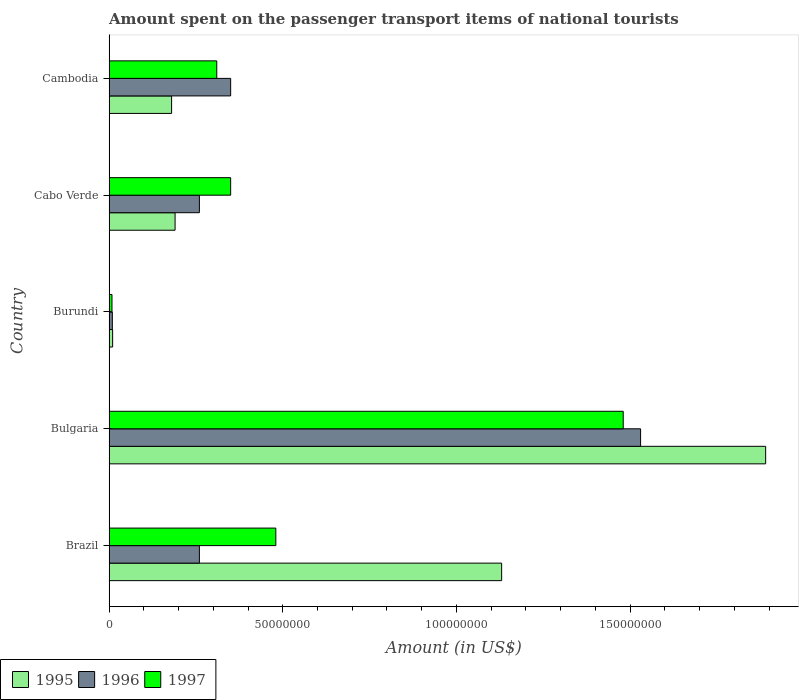How many groups of bars are there?
Ensure brevity in your answer.  5. How many bars are there on the 2nd tick from the top?
Provide a short and direct response. 3. How many bars are there on the 2nd tick from the bottom?
Make the answer very short. 3. What is the label of the 1st group of bars from the top?
Your response must be concise. Cambodia. What is the amount spent on the passenger transport items of national tourists in 1997 in Bulgaria?
Provide a succinct answer. 1.48e+08. Across all countries, what is the maximum amount spent on the passenger transport items of national tourists in 1995?
Your answer should be very brief. 1.89e+08. Across all countries, what is the minimum amount spent on the passenger transport items of national tourists in 1995?
Your answer should be compact. 1.02e+06. In which country was the amount spent on the passenger transport items of national tourists in 1996 minimum?
Your answer should be compact. Burundi. What is the total amount spent on the passenger transport items of national tourists in 1995 in the graph?
Make the answer very short. 3.40e+08. What is the difference between the amount spent on the passenger transport items of national tourists in 1997 in Bulgaria and that in Cambodia?
Make the answer very short. 1.17e+08. What is the difference between the amount spent on the passenger transport items of national tourists in 1995 in Cabo Verde and the amount spent on the passenger transport items of national tourists in 1996 in Cambodia?
Make the answer very short. -1.60e+07. What is the average amount spent on the passenger transport items of national tourists in 1997 per country?
Your answer should be very brief. 5.26e+07. What is the difference between the amount spent on the passenger transport items of national tourists in 1995 and amount spent on the passenger transport items of national tourists in 1996 in Burundi?
Your answer should be very brief. 8.36e+04. What is the ratio of the amount spent on the passenger transport items of national tourists in 1997 in Bulgaria to that in Burundi?
Make the answer very short. 176.18. Is the difference between the amount spent on the passenger transport items of national tourists in 1995 in Bulgaria and Cambodia greater than the difference between the amount spent on the passenger transport items of national tourists in 1996 in Bulgaria and Cambodia?
Offer a terse response. Yes. What is the difference between the highest and the second highest amount spent on the passenger transport items of national tourists in 1995?
Make the answer very short. 7.60e+07. What is the difference between the highest and the lowest amount spent on the passenger transport items of national tourists in 1996?
Keep it short and to the point. 1.52e+08. What does the 2nd bar from the bottom in Burundi represents?
Provide a short and direct response. 1996. Is it the case that in every country, the sum of the amount spent on the passenger transport items of national tourists in 1995 and amount spent on the passenger transport items of national tourists in 1997 is greater than the amount spent on the passenger transport items of national tourists in 1996?
Provide a short and direct response. Yes. How many countries are there in the graph?
Your answer should be very brief. 5. Are the values on the major ticks of X-axis written in scientific E-notation?
Keep it short and to the point. No. Where does the legend appear in the graph?
Provide a short and direct response. Bottom left. What is the title of the graph?
Provide a short and direct response. Amount spent on the passenger transport items of national tourists. What is the Amount (in US$) in 1995 in Brazil?
Provide a succinct answer. 1.13e+08. What is the Amount (in US$) in 1996 in Brazil?
Offer a terse response. 2.60e+07. What is the Amount (in US$) of 1997 in Brazil?
Keep it short and to the point. 4.80e+07. What is the Amount (in US$) of 1995 in Bulgaria?
Keep it short and to the point. 1.89e+08. What is the Amount (in US$) in 1996 in Bulgaria?
Make the answer very short. 1.53e+08. What is the Amount (in US$) of 1997 in Bulgaria?
Your response must be concise. 1.48e+08. What is the Amount (in US$) of 1995 in Burundi?
Your response must be concise. 1.02e+06. What is the Amount (in US$) of 1996 in Burundi?
Your response must be concise. 9.41e+05. What is the Amount (in US$) of 1997 in Burundi?
Make the answer very short. 8.40e+05. What is the Amount (in US$) in 1995 in Cabo Verde?
Offer a very short reply. 1.90e+07. What is the Amount (in US$) of 1996 in Cabo Verde?
Provide a short and direct response. 2.60e+07. What is the Amount (in US$) in 1997 in Cabo Verde?
Your answer should be compact. 3.50e+07. What is the Amount (in US$) of 1995 in Cambodia?
Provide a short and direct response. 1.80e+07. What is the Amount (in US$) in 1996 in Cambodia?
Offer a very short reply. 3.50e+07. What is the Amount (in US$) in 1997 in Cambodia?
Your answer should be very brief. 3.10e+07. Across all countries, what is the maximum Amount (in US$) of 1995?
Your response must be concise. 1.89e+08. Across all countries, what is the maximum Amount (in US$) in 1996?
Offer a very short reply. 1.53e+08. Across all countries, what is the maximum Amount (in US$) in 1997?
Provide a short and direct response. 1.48e+08. Across all countries, what is the minimum Amount (in US$) of 1995?
Provide a succinct answer. 1.02e+06. Across all countries, what is the minimum Amount (in US$) in 1996?
Offer a very short reply. 9.41e+05. Across all countries, what is the minimum Amount (in US$) of 1997?
Your answer should be compact. 8.40e+05. What is the total Amount (in US$) of 1995 in the graph?
Your answer should be very brief. 3.40e+08. What is the total Amount (in US$) in 1996 in the graph?
Give a very brief answer. 2.41e+08. What is the total Amount (in US$) of 1997 in the graph?
Offer a terse response. 2.63e+08. What is the difference between the Amount (in US$) in 1995 in Brazil and that in Bulgaria?
Give a very brief answer. -7.60e+07. What is the difference between the Amount (in US$) in 1996 in Brazil and that in Bulgaria?
Your answer should be very brief. -1.27e+08. What is the difference between the Amount (in US$) of 1997 in Brazil and that in Bulgaria?
Offer a terse response. -1.00e+08. What is the difference between the Amount (in US$) in 1995 in Brazil and that in Burundi?
Provide a short and direct response. 1.12e+08. What is the difference between the Amount (in US$) in 1996 in Brazil and that in Burundi?
Your answer should be compact. 2.51e+07. What is the difference between the Amount (in US$) in 1997 in Brazil and that in Burundi?
Your answer should be compact. 4.72e+07. What is the difference between the Amount (in US$) of 1995 in Brazil and that in Cabo Verde?
Provide a succinct answer. 9.40e+07. What is the difference between the Amount (in US$) of 1996 in Brazil and that in Cabo Verde?
Give a very brief answer. 0. What is the difference between the Amount (in US$) in 1997 in Brazil and that in Cabo Verde?
Offer a terse response. 1.30e+07. What is the difference between the Amount (in US$) in 1995 in Brazil and that in Cambodia?
Your answer should be very brief. 9.50e+07. What is the difference between the Amount (in US$) in 1996 in Brazil and that in Cambodia?
Your answer should be very brief. -9.00e+06. What is the difference between the Amount (in US$) in 1997 in Brazil and that in Cambodia?
Make the answer very short. 1.70e+07. What is the difference between the Amount (in US$) in 1995 in Bulgaria and that in Burundi?
Offer a very short reply. 1.88e+08. What is the difference between the Amount (in US$) of 1996 in Bulgaria and that in Burundi?
Your response must be concise. 1.52e+08. What is the difference between the Amount (in US$) in 1997 in Bulgaria and that in Burundi?
Offer a terse response. 1.47e+08. What is the difference between the Amount (in US$) of 1995 in Bulgaria and that in Cabo Verde?
Make the answer very short. 1.70e+08. What is the difference between the Amount (in US$) in 1996 in Bulgaria and that in Cabo Verde?
Make the answer very short. 1.27e+08. What is the difference between the Amount (in US$) of 1997 in Bulgaria and that in Cabo Verde?
Ensure brevity in your answer.  1.13e+08. What is the difference between the Amount (in US$) of 1995 in Bulgaria and that in Cambodia?
Offer a terse response. 1.71e+08. What is the difference between the Amount (in US$) of 1996 in Bulgaria and that in Cambodia?
Give a very brief answer. 1.18e+08. What is the difference between the Amount (in US$) in 1997 in Bulgaria and that in Cambodia?
Your answer should be very brief. 1.17e+08. What is the difference between the Amount (in US$) of 1995 in Burundi and that in Cabo Verde?
Offer a terse response. -1.80e+07. What is the difference between the Amount (in US$) of 1996 in Burundi and that in Cabo Verde?
Give a very brief answer. -2.51e+07. What is the difference between the Amount (in US$) of 1997 in Burundi and that in Cabo Verde?
Offer a terse response. -3.42e+07. What is the difference between the Amount (in US$) in 1995 in Burundi and that in Cambodia?
Offer a very short reply. -1.70e+07. What is the difference between the Amount (in US$) in 1996 in Burundi and that in Cambodia?
Offer a terse response. -3.41e+07. What is the difference between the Amount (in US$) in 1997 in Burundi and that in Cambodia?
Provide a short and direct response. -3.02e+07. What is the difference between the Amount (in US$) of 1995 in Cabo Verde and that in Cambodia?
Your response must be concise. 1.00e+06. What is the difference between the Amount (in US$) in 1996 in Cabo Verde and that in Cambodia?
Provide a succinct answer. -9.00e+06. What is the difference between the Amount (in US$) in 1995 in Brazil and the Amount (in US$) in 1996 in Bulgaria?
Offer a very short reply. -4.00e+07. What is the difference between the Amount (in US$) of 1995 in Brazil and the Amount (in US$) of 1997 in Bulgaria?
Offer a terse response. -3.50e+07. What is the difference between the Amount (in US$) of 1996 in Brazil and the Amount (in US$) of 1997 in Bulgaria?
Make the answer very short. -1.22e+08. What is the difference between the Amount (in US$) in 1995 in Brazil and the Amount (in US$) in 1996 in Burundi?
Offer a terse response. 1.12e+08. What is the difference between the Amount (in US$) in 1995 in Brazil and the Amount (in US$) in 1997 in Burundi?
Provide a succinct answer. 1.12e+08. What is the difference between the Amount (in US$) in 1996 in Brazil and the Amount (in US$) in 1997 in Burundi?
Your answer should be very brief. 2.52e+07. What is the difference between the Amount (in US$) of 1995 in Brazil and the Amount (in US$) of 1996 in Cabo Verde?
Provide a succinct answer. 8.70e+07. What is the difference between the Amount (in US$) of 1995 in Brazil and the Amount (in US$) of 1997 in Cabo Verde?
Your answer should be compact. 7.80e+07. What is the difference between the Amount (in US$) in 1996 in Brazil and the Amount (in US$) in 1997 in Cabo Verde?
Ensure brevity in your answer.  -9.00e+06. What is the difference between the Amount (in US$) in 1995 in Brazil and the Amount (in US$) in 1996 in Cambodia?
Provide a succinct answer. 7.80e+07. What is the difference between the Amount (in US$) in 1995 in Brazil and the Amount (in US$) in 1997 in Cambodia?
Ensure brevity in your answer.  8.20e+07. What is the difference between the Amount (in US$) in 1996 in Brazil and the Amount (in US$) in 1997 in Cambodia?
Your response must be concise. -5.00e+06. What is the difference between the Amount (in US$) in 1995 in Bulgaria and the Amount (in US$) in 1996 in Burundi?
Your answer should be very brief. 1.88e+08. What is the difference between the Amount (in US$) in 1995 in Bulgaria and the Amount (in US$) in 1997 in Burundi?
Your answer should be compact. 1.88e+08. What is the difference between the Amount (in US$) of 1996 in Bulgaria and the Amount (in US$) of 1997 in Burundi?
Your answer should be very brief. 1.52e+08. What is the difference between the Amount (in US$) in 1995 in Bulgaria and the Amount (in US$) in 1996 in Cabo Verde?
Provide a short and direct response. 1.63e+08. What is the difference between the Amount (in US$) of 1995 in Bulgaria and the Amount (in US$) of 1997 in Cabo Verde?
Offer a very short reply. 1.54e+08. What is the difference between the Amount (in US$) in 1996 in Bulgaria and the Amount (in US$) in 1997 in Cabo Verde?
Keep it short and to the point. 1.18e+08. What is the difference between the Amount (in US$) of 1995 in Bulgaria and the Amount (in US$) of 1996 in Cambodia?
Ensure brevity in your answer.  1.54e+08. What is the difference between the Amount (in US$) in 1995 in Bulgaria and the Amount (in US$) in 1997 in Cambodia?
Your answer should be compact. 1.58e+08. What is the difference between the Amount (in US$) in 1996 in Bulgaria and the Amount (in US$) in 1997 in Cambodia?
Make the answer very short. 1.22e+08. What is the difference between the Amount (in US$) of 1995 in Burundi and the Amount (in US$) of 1996 in Cabo Verde?
Provide a short and direct response. -2.50e+07. What is the difference between the Amount (in US$) of 1995 in Burundi and the Amount (in US$) of 1997 in Cabo Verde?
Keep it short and to the point. -3.40e+07. What is the difference between the Amount (in US$) of 1996 in Burundi and the Amount (in US$) of 1997 in Cabo Verde?
Give a very brief answer. -3.41e+07. What is the difference between the Amount (in US$) of 1995 in Burundi and the Amount (in US$) of 1996 in Cambodia?
Your answer should be compact. -3.40e+07. What is the difference between the Amount (in US$) of 1995 in Burundi and the Amount (in US$) of 1997 in Cambodia?
Provide a succinct answer. -3.00e+07. What is the difference between the Amount (in US$) in 1996 in Burundi and the Amount (in US$) in 1997 in Cambodia?
Your answer should be very brief. -3.01e+07. What is the difference between the Amount (in US$) of 1995 in Cabo Verde and the Amount (in US$) of 1996 in Cambodia?
Your answer should be compact. -1.60e+07. What is the difference between the Amount (in US$) in 1995 in Cabo Verde and the Amount (in US$) in 1997 in Cambodia?
Your response must be concise. -1.20e+07. What is the difference between the Amount (in US$) in 1996 in Cabo Verde and the Amount (in US$) in 1997 in Cambodia?
Give a very brief answer. -5.00e+06. What is the average Amount (in US$) in 1995 per country?
Provide a succinct answer. 6.80e+07. What is the average Amount (in US$) in 1996 per country?
Offer a terse response. 4.82e+07. What is the average Amount (in US$) of 1997 per country?
Keep it short and to the point. 5.26e+07. What is the difference between the Amount (in US$) in 1995 and Amount (in US$) in 1996 in Brazil?
Ensure brevity in your answer.  8.70e+07. What is the difference between the Amount (in US$) in 1995 and Amount (in US$) in 1997 in Brazil?
Offer a very short reply. 6.50e+07. What is the difference between the Amount (in US$) of 1996 and Amount (in US$) of 1997 in Brazil?
Give a very brief answer. -2.20e+07. What is the difference between the Amount (in US$) of 1995 and Amount (in US$) of 1996 in Bulgaria?
Make the answer very short. 3.60e+07. What is the difference between the Amount (in US$) of 1995 and Amount (in US$) of 1997 in Bulgaria?
Offer a terse response. 4.10e+07. What is the difference between the Amount (in US$) of 1995 and Amount (in US$) of 1996 in Burundi?
Your answer should be very brief. 8.36e+04. What is the difference between the Amount (in US$) of 1995 and Amount (in US$) of 1997 in Burundi?
Offer a terse response. 1.85e+05. What is the difference between the Amount (in US$) in 1996 and Amount (in US$) in 1997 in Burundi?
Keep it short and to the point. 1.01e+05. What is the difference between the Amount (in US$) of 1995 and Amount (in US$) of 1996 in Cabo Verde?
Provide a short and direct response. -7.00e+06. What is the difference between the Amount (in US$) in 1995 and Amount (in US$) in 1997 in Cabo Verde?
Ensure brevity in your answer.  -1.60e+07. What is the difference between the Amount (in US$) of 1996 and Amount (in US$) of 1997 in Cabo Verde?
Make the answer very short. -9.00e+06. What is the difference between the Amount (in US$) in 1995 and Amount (in US$) in 1996 in Cambodia?
Your response must be concise. -1.70e+07. What is the difference between the Amount (in US$) of 1995 and Amount (in US$) of 1997 in Cambodia?
Your answer should be compact. -1.30e+07. What is the difference between the Amount (in US$) in 1996 and Amount (in US$) in 1997 in Cambodia?
Your response must be concise. 4.00e+06. What is the ratio of the Amount (in US$) of 1995 in Brazil to that in Bulgaria?
Make the answer very short. 0.6. What is the ratio of the Amount (in US$) of 1996 in Brazil to that in Bulgaria?
Your answer should be compact. 0.17. What is the ratio of the Amount (in US$) of 1997 in Brazil to that in Bulgaria?
Ensure brevity in your answer.  0.32. What is the ratio of the Amount (in US$) of 1995 in Brazil to that in Burundi?
Ensure brevity in your answer.  110.24. What is the ratio of the Amount (in US$) in 1996 in Brazil to that in Burundi?
Ensure brevity in your answer.  27.62. What is the ratio of the Amount (in US$) of 1997 in Brazil to that in Burundi?
Give a very brief answer. 57.14. What is the ratio of the Amount (in US$) in 1995 in Brazil to that in Cabo Verde?
Ensure brevity in your answer.  5.95. What is the ratio of the Amount (in US$) in 1996 in Brazil to that in Cabo Verde?
Provide a succinct answer. 1. What is the ratio of the Amount (in US$) of 1997 in Brazil to that in Cabo Verde?
Give a very brief answer. 1.37. What is the ratio of the Amount (in US$) in 1995 in Brazil to that in Cambodia?
Your answer should be very brief. 6.28. What is the ratio of the Amount (in US$) of 1996 in Brazil to that in Cambodia?
Make the answer very short. 0.74. What is the ratio of the Amount (in US$) of 1997 in Brazil to that in Cambodia?
Keep it short and to the point. 1.55. What is the ratio of the Amount (in US$) in 1995 in Bulgaria to that in Burundi?
Give a very brief answer. 184.39. What is the ratio of the Amount (in US$) in 1996 in Bulgaria to that in Burundi?
Offer a terse response. 162.53. What is the ratio of the Amount (in US$) of 1997 in Bulgaria to that in Burundi?
Provide a short and direct response. 176.18. What is the ratio of the Amount (in US$) of 1995 in Bulgaria to that in Cabo Verde?
Your answer should be compact. 9.95. What is the ratio of the Amount (in US$) in 1996 in Bulgaria to that in Cabo Verde?
Your answer should be compact. 5.88. What is the ratio of the Amount (in US$) of 1997 in Bulgaria to that in Cabo Verde?
Offer a terse response. 4.23. What is the ratio of the Amount (in US$) of 1995 in Bulgaria to that in Cambodia?
Provide a succinct answer. 10.5. What is the ratio of the Amount (in US$) of 1996 in Bulgaria to that in Cambodia?
Make the answer very short. 4.37. What is the ratio of the Amount (in US$) of 1997 in Bulgaria to that in Cambodia?
Make the answer very short. 4.77. What is the ratio of the Amount (in US$) in 1995 in Burundi to that in Cabo Verde?
Give a very brief answer. 0.05. What is the ratio of the Amount (in US$) in 1996 in Burundi to that in Cabo Verde?
Provide a short and direct response. 0.04. What is the ratio of the Amount (in US$) of 1997 in Burundi to that in Cabo Verde?
Offer a very short reply. 0.02. What is the ratio of the Amount (in US$) of 1995 in Burundi to that in Cambodia?
Your answer should be very brief. 0.06. What is the ratio of the Amount (in US$) of 1996 in Burundi to that in Cambodia?
Your response must be concise. 0.03. What is the ratio of the Amount (in US$) in 1997 in Burundi to that in Cambodia?
Ensure brevity in your answer.  0.03. What is the ratio of the Amount (in US$) in 1995 in Cabo Verde to that in Cambodia?
Keep it short and to the point. 1.06. What is the ratio of the Amount (in US$) in 1996 in Cabo Verde to that in Cambodia?
Provide a succinct answer. 0.74. What is the ratio of the Amount (in US$) of 1997 in Cabo Verde to that in Cambodia?
Keep it short and to the point. 1.13. What is the difference between the highest and the second highest Amount (in US$) in 1995?
Ensure brevity in your answer.  7.60e+07. What is the difference between the highest and the second highest Amount (in US$) in 1996?
Give a very brief answer. 1.18e+08. What is the difference between the highest and the lowest Amount (in US$) in 1995?
Offer a very short reply. 1.88e+08. What is the difference between the highest and the lowest Amount (in US$) in 1996?
Provide a succinct answer. 1.52e+08. What is the difference between the highest and the lowest Amount (in US$) in 1997?
Keep it short and to the point. 1.47e+08. 